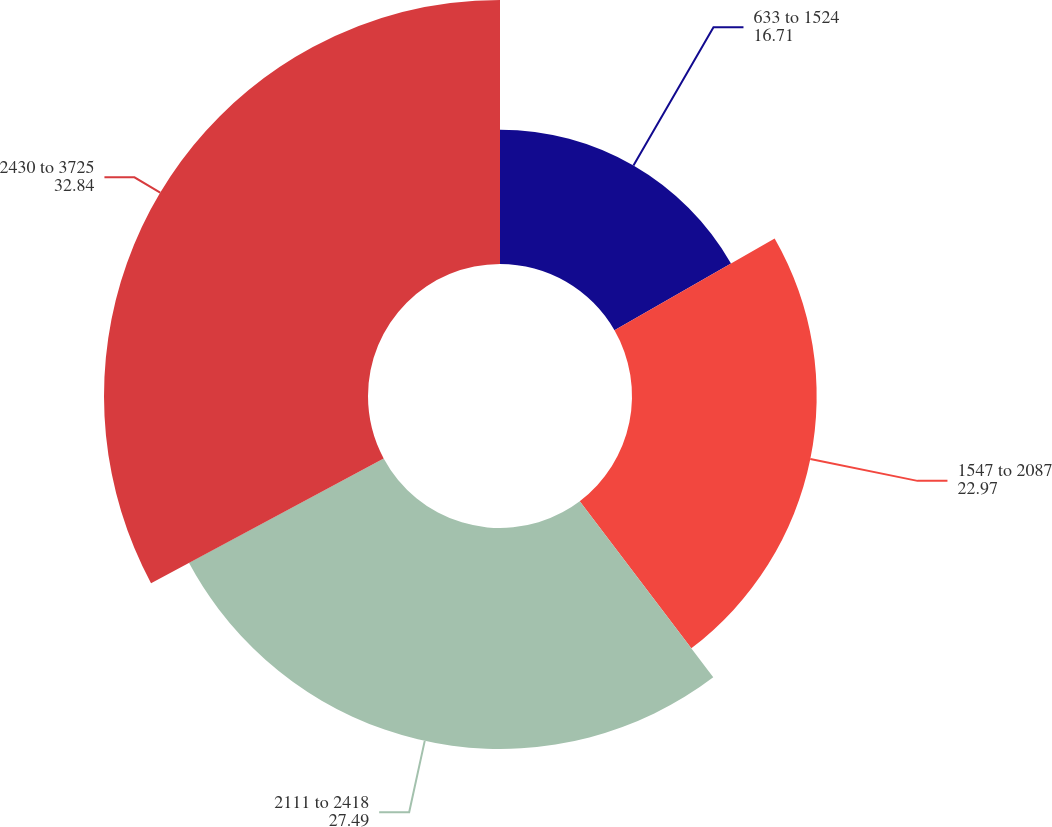Convert chart. <chart><loc_0><loc_0><loc_500><loc_500><pie_chart><fcel>633 to 1524<fcel>1547 to 2087<fcel>2111 to 2418<fcel>2430 to 3725<nl><fcel>16.71%<fcel>22.97%<fcel>27.49%<fcel>32.84%<nl></chart> 